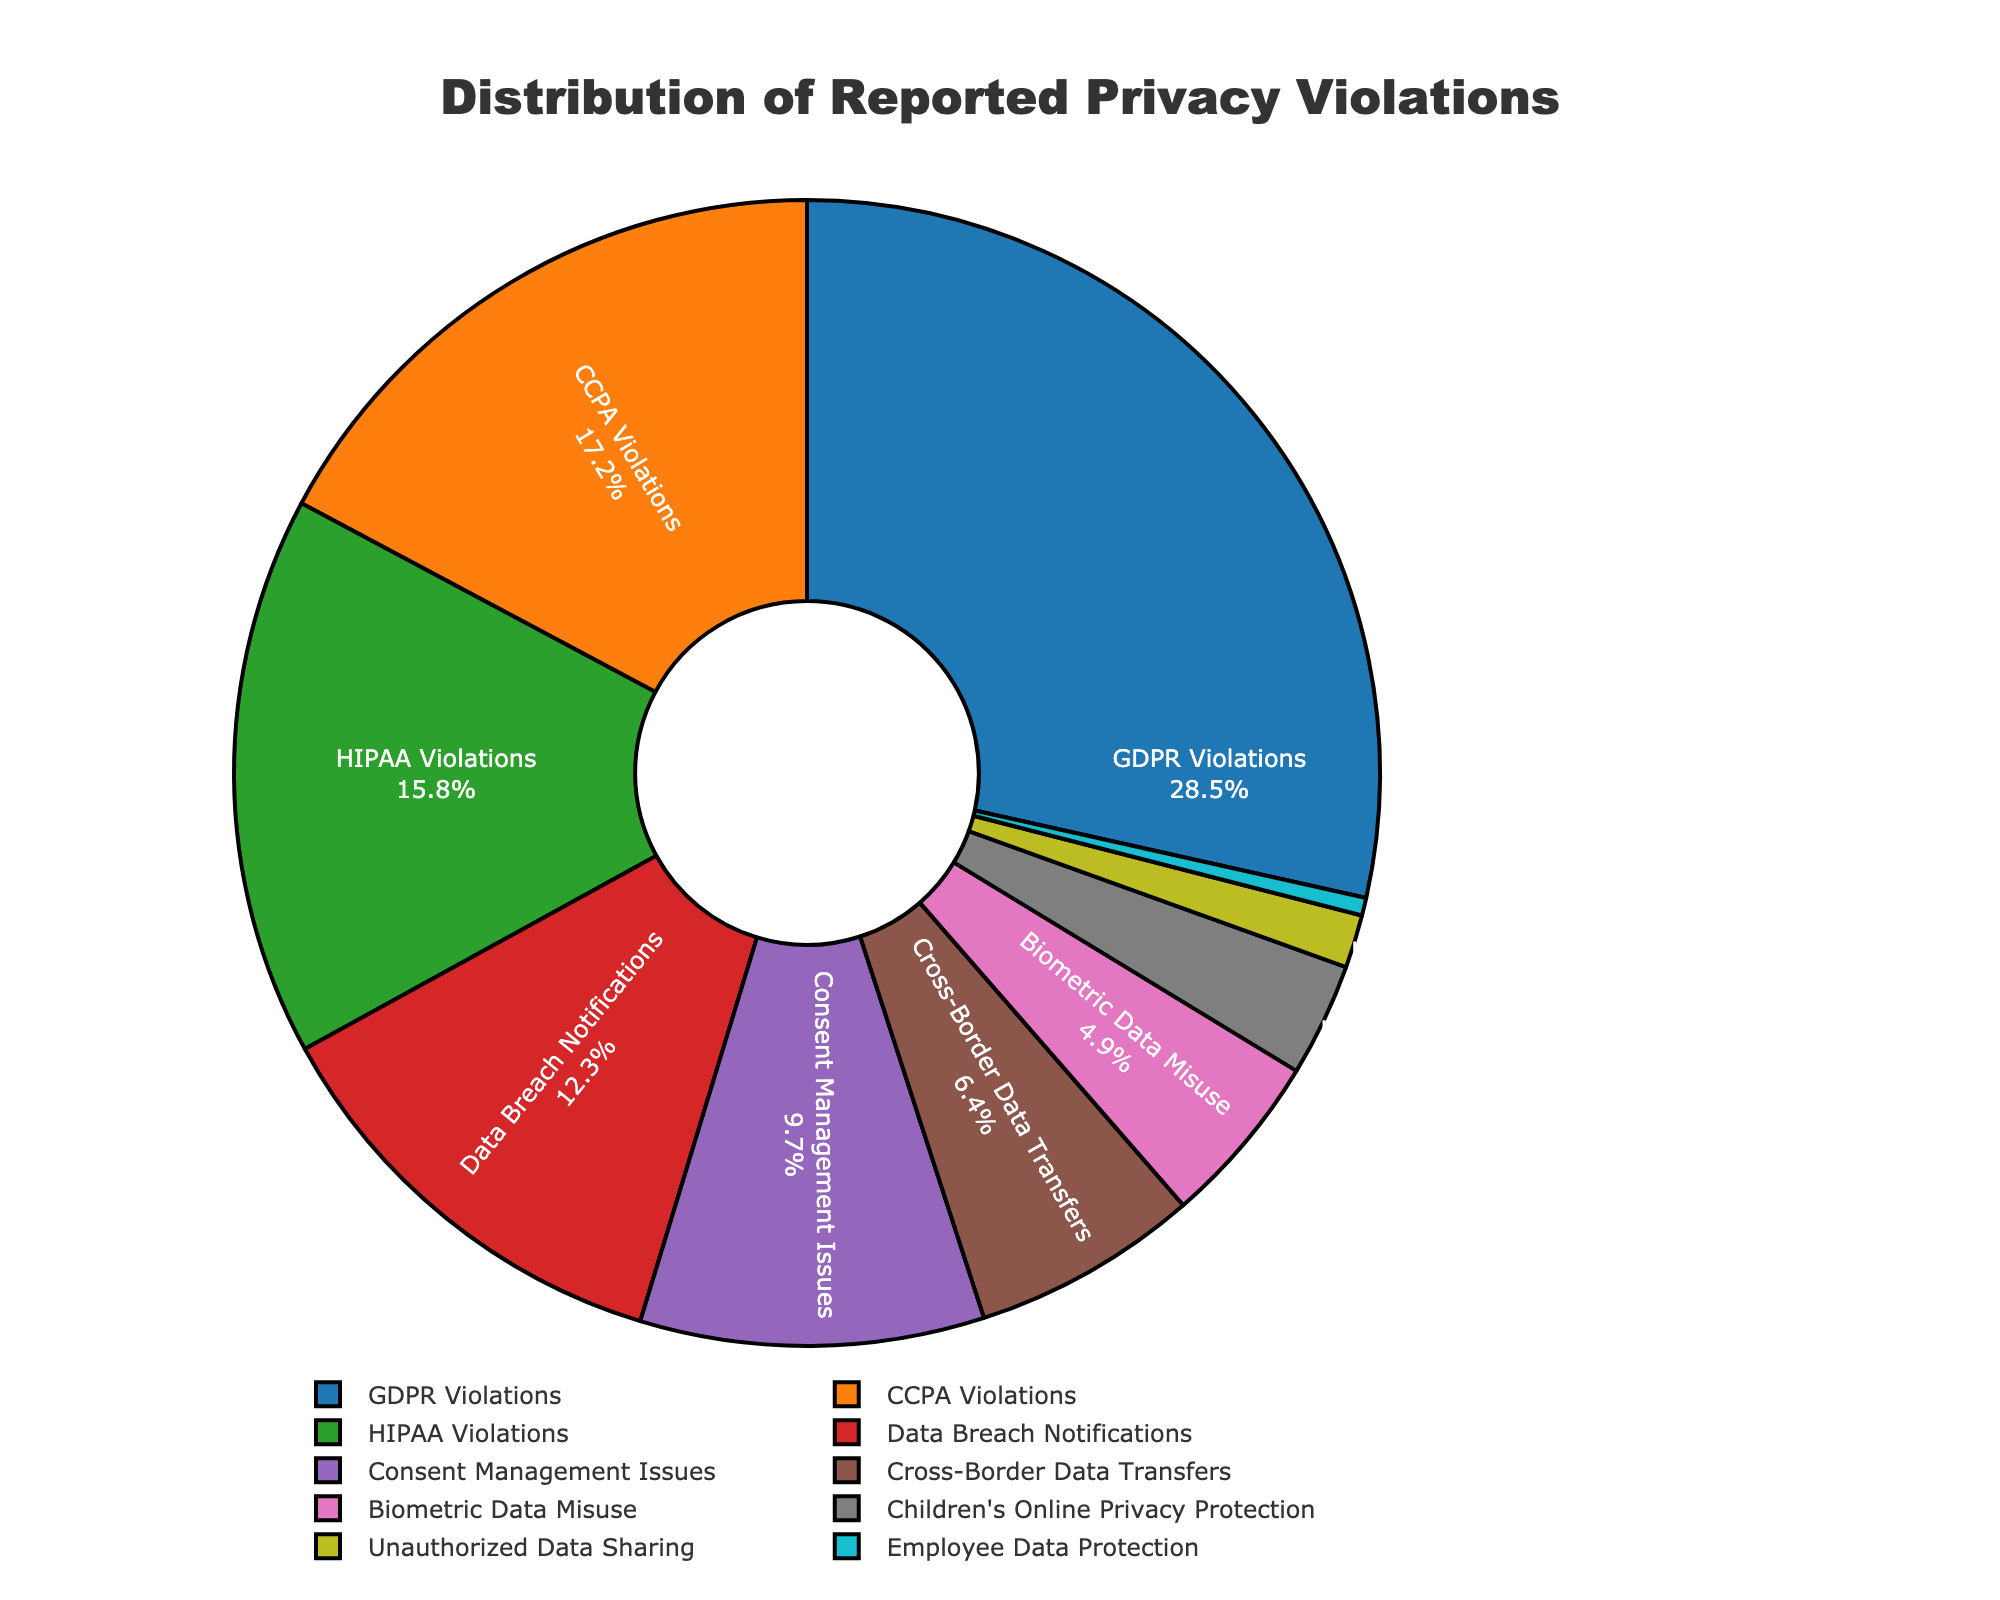What is the percentage of GDPR Violations? The GDPR Violations segment in the pie chart shows 28.5%. Thus, the percentage of GDPR Violations is 28.5%.
Answer: 28.5% Which category has the smallest proportion of reported privacy violations? The pie chart shows the Employee Data Protection category with a segment corresponding to 0.5%, which is the smallest proportion among all categories.
Answer: Employee Data Protection How much larger is the percentage of GDPR Violations compared to CCPA Violations? The pie chart shows GDPR Violations at 28.5% and CCPA Violations at 17.2%. Subtracting these gives 28.5% - 17.2% = 11.3%.
Answer: 11.3% What is the combined percentage of HIPAA Violations and Data Breach Notifications? The pie chart indicates HIPAA Violations at 15.8% and Data Breach Notifications at 12.3%. Adding these together gives 15.8% + 12.3% = 28.1%.
Answer: 28.1% Are Consent Management Issues reported more frequently than Cross-Border Data Transfers? By visually comparing the segments in the pie chart, Consent Management Issues are at 9.7% while Cross-Border Data Transfers are at 6.4%. Since 9.7% is greater than 6.4%, Consent Management Issues are reported more frequently.
Answer: Yes What is the visual color associated with Biometric Data Misuse? The Biometric Data Misuse segment in the pie chart is shaded in pink.
Answer: Pink Which categories together make up more than 50% of the reported privacy violations? Adding percentages from the pie chart:
GDPR Violations (28.5%) + CCPA Violations (17.2%) = 45.7% 
Adding HIPAA Violations (15.8%) to 45.7% = 61.5%. 
Thus, GDPR Violations, CCPA Violations, and HIPAA Violations total more than 50%.
Answer: GDPR Violations, CCPA Violations, HIPAA Violations What is the percentage difference between Children's Online Privacy Protection and Unauthorized Data Sharing categories? The pie chart shows 3.2% for Children's Online Privacy Protection and 1.5% for Unauthorized Data Sharing. Subtracting these gives 3.2% - 1.5% = 1.7%.
Answer: 1.7% In terms of reported privacy violations, do Data Breach Notifications contribute more than Biometric Data Misuse? The pie chart shows Data Breach Notifications at 12.3% and Biometric Data Misuse at 4.9%. Since 12.3% is greater than 4.9%, Data Breach Notifications contribute more.
Answer: Yes How does the percentage of Biometric Data Misuse compare to Children’s Online Privacy Protection? The pie chart shows Biometric Data Misuse at 4.9% and Children's Online Privacy Protection at 3.2%. Since 4.9% is greater than 3.2%, Biometric Data Misuse is higher.
Answer: Biometric Data Misuse is higher 